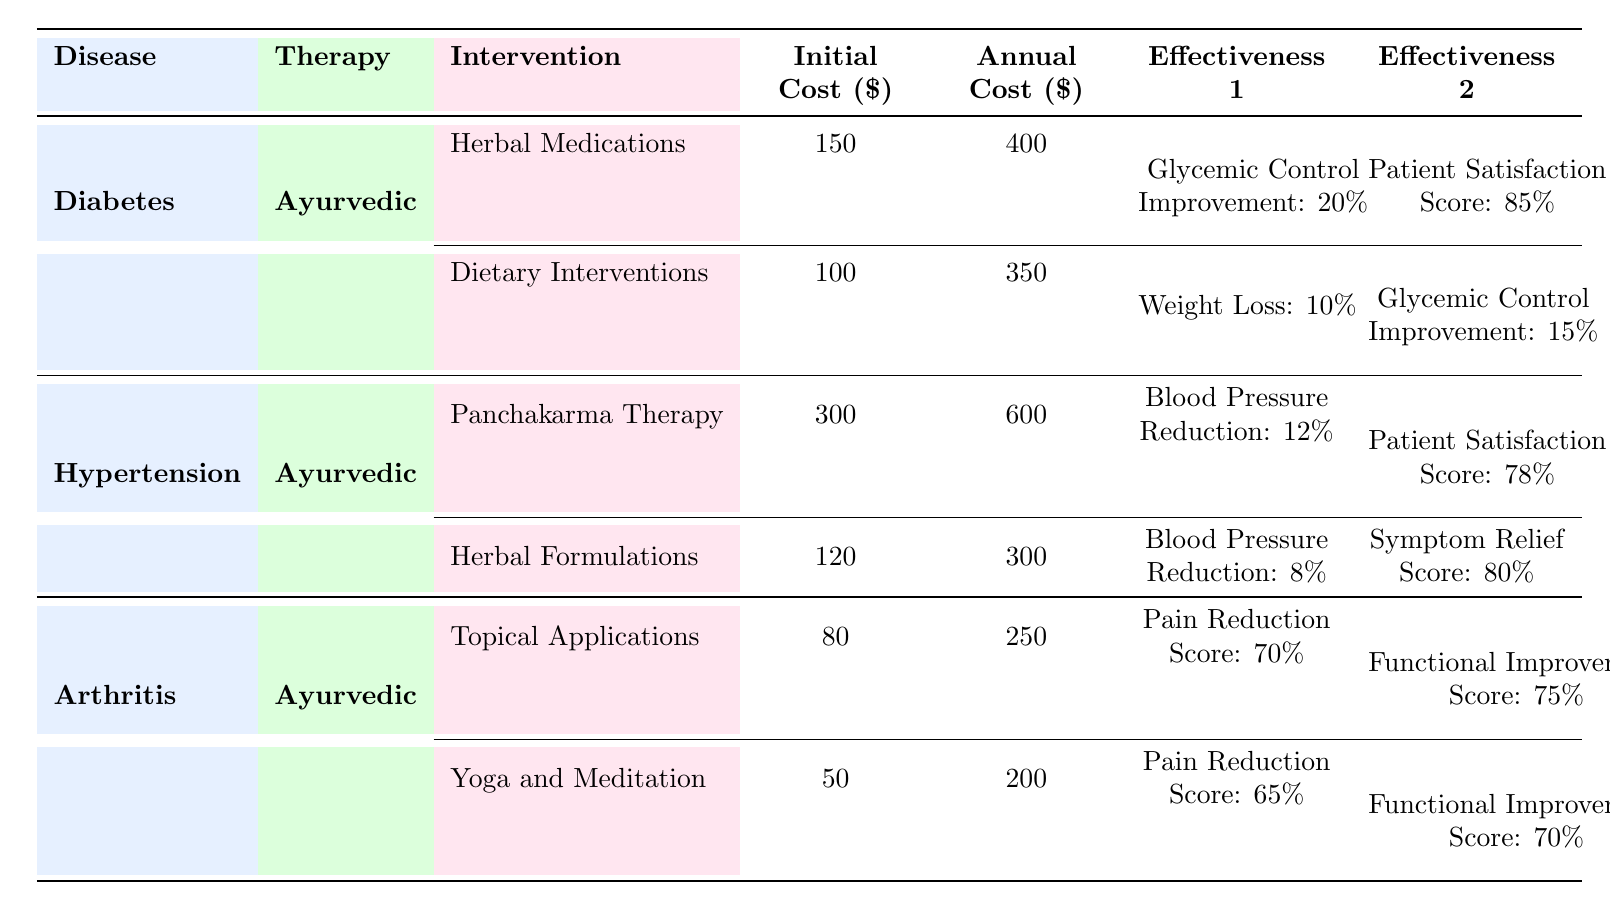What is the initial cost of Herbal Medications for diabetes? The table indicates that the Initial Cost for Herbal Medications under Diabetes is $150.
Answer: 150 What is the annual cost of Yoga and Meditation for arthritis? According to the table, the Annual Cost for Yoga and Meditation for arthritis is $200.
Answer: 200 Do dietary interventions provide a higher glycemic control improvement than herbal medications for diabetes? For dietary interventions, the Glycemic Control Improvement is 15%, while for herbal medications, it is 20%. Since 15% is less than 20%, the statement is false.
Answer: No Which Ayurvedic therapy for hypertension has the highest initial cost? Looking at the table, Panchakarma Therapy has the highest Initial Cost listed at $300 compared to Herbal Formulations at $120.
Answer: Panchakarma Therapy What is the total annual cost of all Ayurvedic interventions for diabetes? The Annual Costs for diabetes interventions are Herbal Medications at $400 and Dietary Interventions at $350. The total annual cost is 400 + 350 = 750.
Answer: 750 Is the Patient Satisfaction Score for Panchakarma Therapy higher than that of Herbal Formulations? The Patient Satisfaction Score for Panchakarma Therapy is 78, while for Herbal Formulations, it is 80. Since 78 is less than 80, the statement is false.
Answer: No What is the average pain reduction score for the Ayurvedic therapies for arthritis? The Pain Reduction Scores are 70 for Topical Applications and 65 for Yoga and Meditation. To find the average, we sum them: 70 + 65 = 135, then divide by 2, giving us an average of 135/2 = 67.5.
Answer: 67.5 Which Ayurvedic therapy for diabetes has a higher patient satisfaction score: Herbal Medications or Dietary Interventions? The Patient Satisfaction Score for Herbal Medications is 85%, while for Dietary Interventions, it is not specified but is lower than 85%. Thus, Herbal Medications has the higher score.
Answer: Herbal Medications What is the difference in annual cost between Panchakarma Therapy and Herbal Formulations for hypertension? The Annual Cost for Panchakarma Therapy is $600, and for Herbal Formulations, it is $300. Therefore, the difference is 600 - 300 = 300.
Answer: 300 